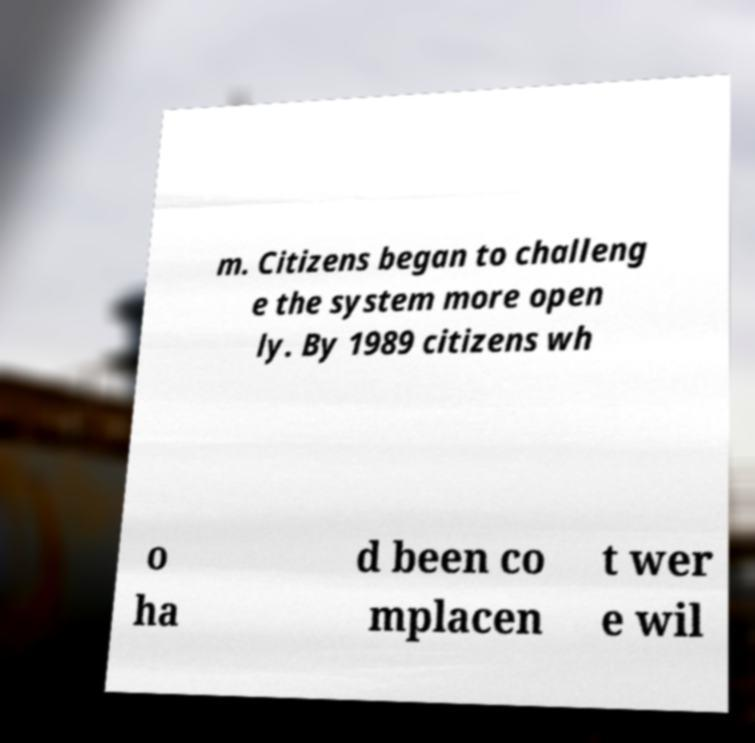Please identify and transcribe the text found in this image. m. Citizens began to challeng e the system more open ly. By 1989 citizens wh o ha d been co mplacen t wer e wil 